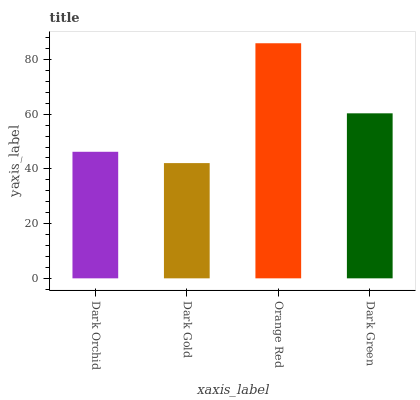Is Dark Gold the minimum?
Answer yes or no. Yes. Is Orange Red the maximum?
Answer yes or no. Yes. Is Orange Red the minimum?
Answer yes or no. No. Is Dark Gold the maximum?
Answer yes or no. No. Is Orange Red greater than Dark Gold?
Answer yes or no. Yes. Is Dark Gold less than Orange Red?
Answer yes or no. Yes. Is Dark Gold greater than Orange Red?
Answer yes or no. No. Is Orange Red less than Dark Gold?
Answer yes or no. No. Is Dark Green the high median?
Answer yes or no. Yes. Is Dark Orchid the low median?
Answer yes or no. Yes. Is Dark Gold the high median?
Answer yes or no. No. Is Dark Green the low median?
Answer yes or no. No. 